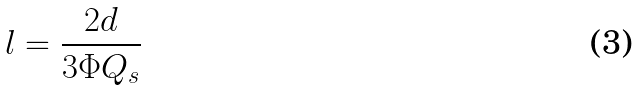Convert formula to latex. <formula><loc_0><loc_0><loc_500><loc_500>l = \frac { 2 d } { 3 \Phi Q _ { s } }</formula> 